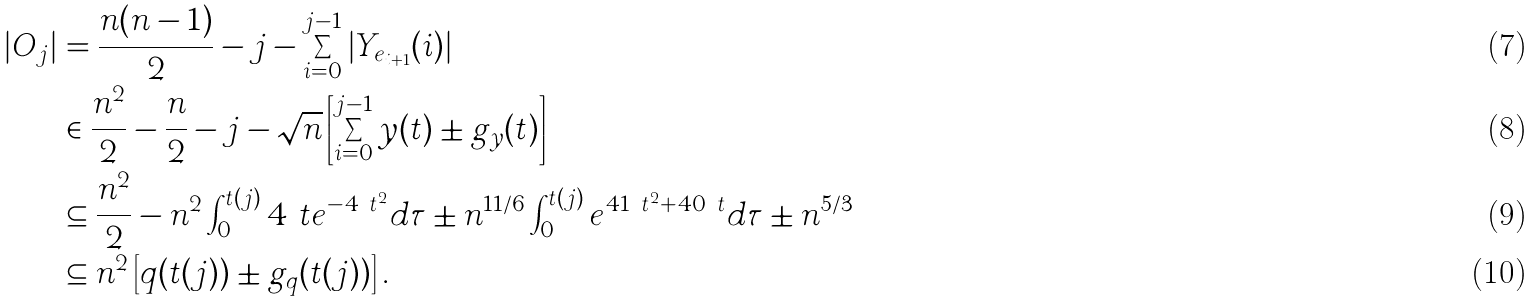Convert formula to latex. <formula><loc_0><loc_0><loc_500><loc_500>| O _ { j } | & = \frac { n ( n - 1 ) } { 2 } - j - \sum _ { i = 0 } ^ { j - 1 } \left | Y _ { e _ { i + 1 } } ( i ) \right | \\ & \in \frac { n ^ { 2 } } { 2 } - \frac { n } { 2 } - j - \sqrt { n } \left [ \sum _ { i = 0 } ^ { j - 1 } y ( t ) \pm g _ { y } ( t ) \right ] \\ & \subseteq \frac { n ^ { 2 } } { 2 } - n ^ { 2 } \int _ { 0 } ^ { t ( j ) } 4 \ t e ^ { - 4 \ t ^ { 2 } } d \tau \pm n ^ { 1 1 / 6 } \int _ { 0 } ^ { t ( j ) } e ^ { 4 1 \ t ^ { 2 } + 4 0 \ t } d \tau \pm n ^ { 5 / 3 } \\ & \subseteq n ^ { 2 } \left [ q ( t ( j ) ) \pm g _ { q } ( t ( j ) ) \right ] .</formula> 